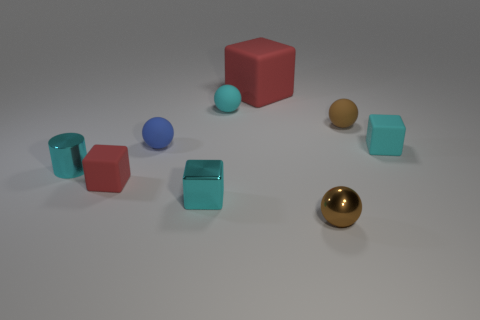What number of cubes are either yellow rubber things or large things?
Provide a short and direct response. 1. Does the object left of the tiny red matte cube have the same color as the large cube?
Your answer should be compact. No. What material is the small brown sphere that is to the right of the small brown thing that is in front of the cyan block that is behind the small red object?
Offer a terse response. Rubber. Is the metallic cylinder the same size as the blue sphere?
Offer a very short reply. Yes. There is a big cube; is its color the same as the ball that is in front of the tiny red matte object?
Provide a succinct answer. No. The cyan object that is made of the same material as the small cyan cylinder is what shape?
Keep it short and to the point. Cube. Do the red thing to the left of the small cyan metal cube and the small blue object have the same shape?
Make the answer very short. No. What is the size of the metallic sphere that is left of the tiny cyan cube that is on the right side of the tiny cyan metal block?
Offer a very short reply. Small. The tiny ball that is made of the same material as the cylinder is what color?
Make the answer very short. Brown. How many blue spheres are the same size as the blue thing?
Your response must be concise. 0. 